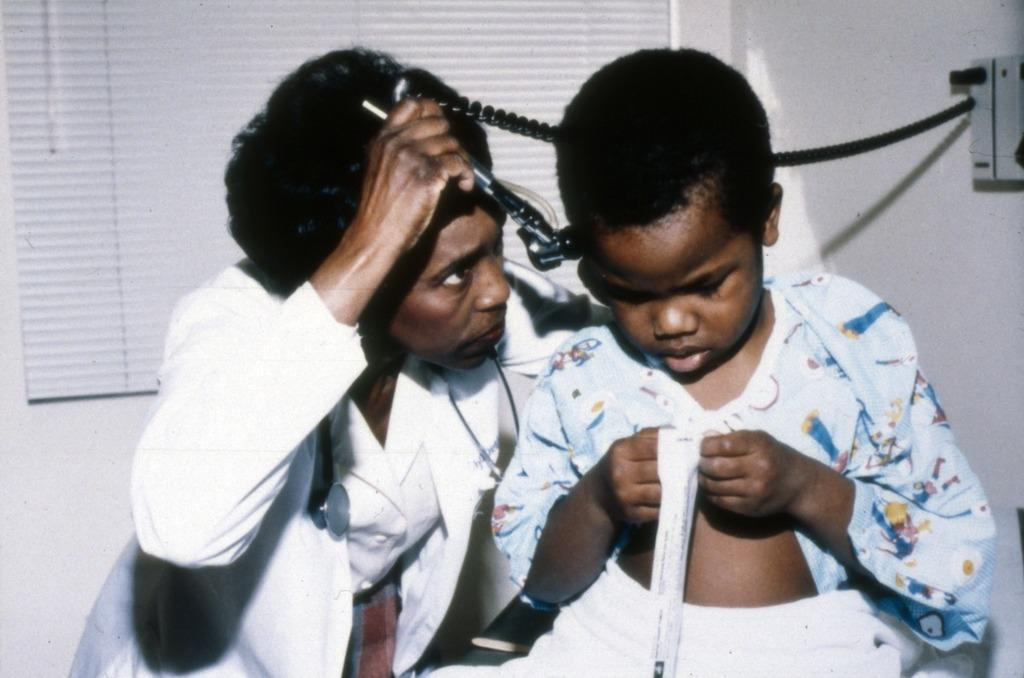Who is the main subject in the image? There is a woman in the image. What is the woman wearing? The woman is wearing a white coat. What is the woman doing in the image? The woman is examining a boy. Where is the boy positioned in relation to the woman? The boy is beside the woman. What can be seen in the background of the image? There is a window on the wall in the background of the image. What type of paste is being used by the woman to examine the boy's hour? There is no paste or hour mentioned in the image; the woman is examining the boy without any visible tools or equipment. 